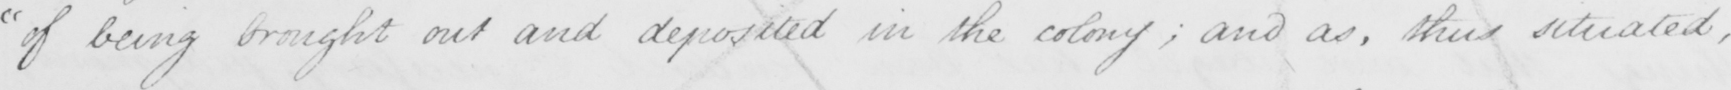Transcribe the text shown in this historical manuscript line. " of being brought out and deposited in the colony ; and as , thus situated , 